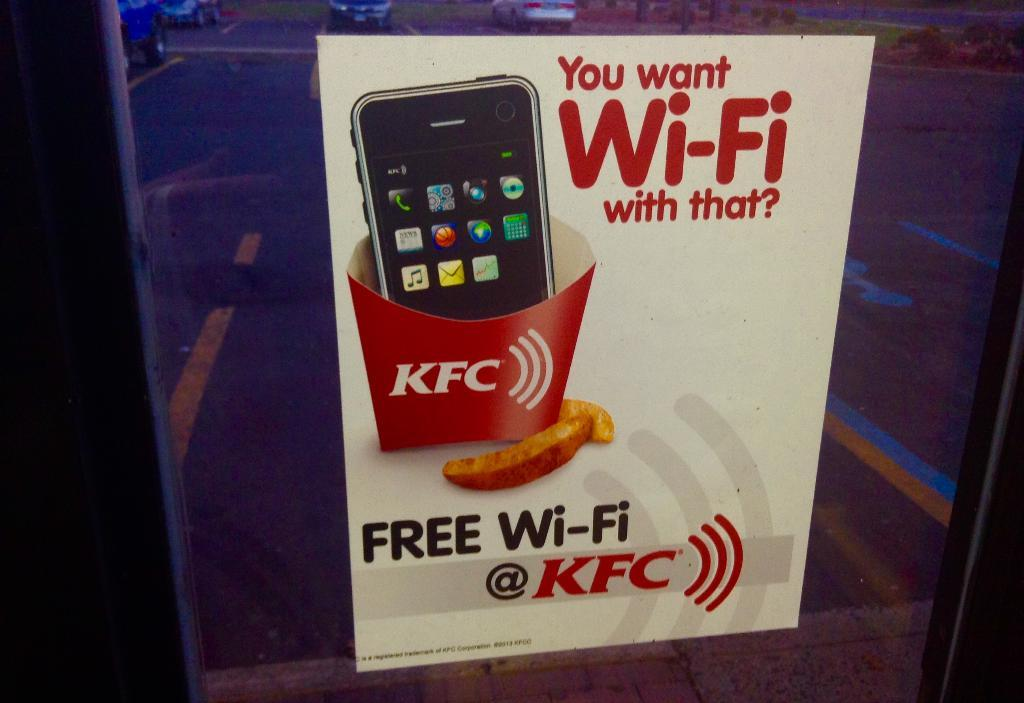<image>
Offer a succinct explanation of the picture presented. An advertisement for free Wi-Fi at KFC on a glass window. 